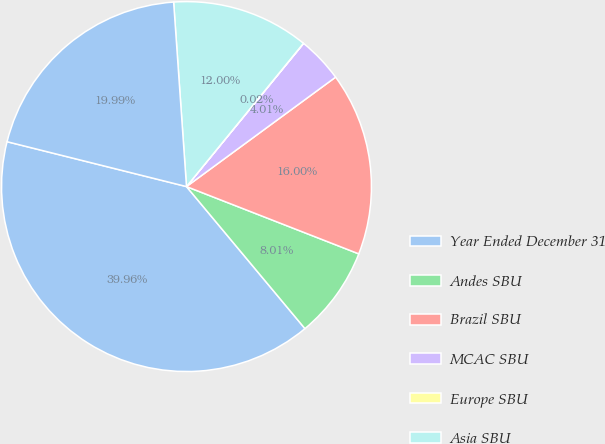Convert chart. <chart><loc_0><loc_0><loc_500><loc_500><pie_chart><fcel>Year Ended December 31<fcel>Andes SBU<fcel>Brazil SBU<fcel>MCAC SBU<fcel>Europe SBU<fcel>Asia SBU<fcel>Total<nl><fcel>39.96%<fcel>8.01%<fcel>16.0%<fcel>4.01%<fcel>0.02%<fcel>12.0%<fcel>19.99%<nl></chart> 